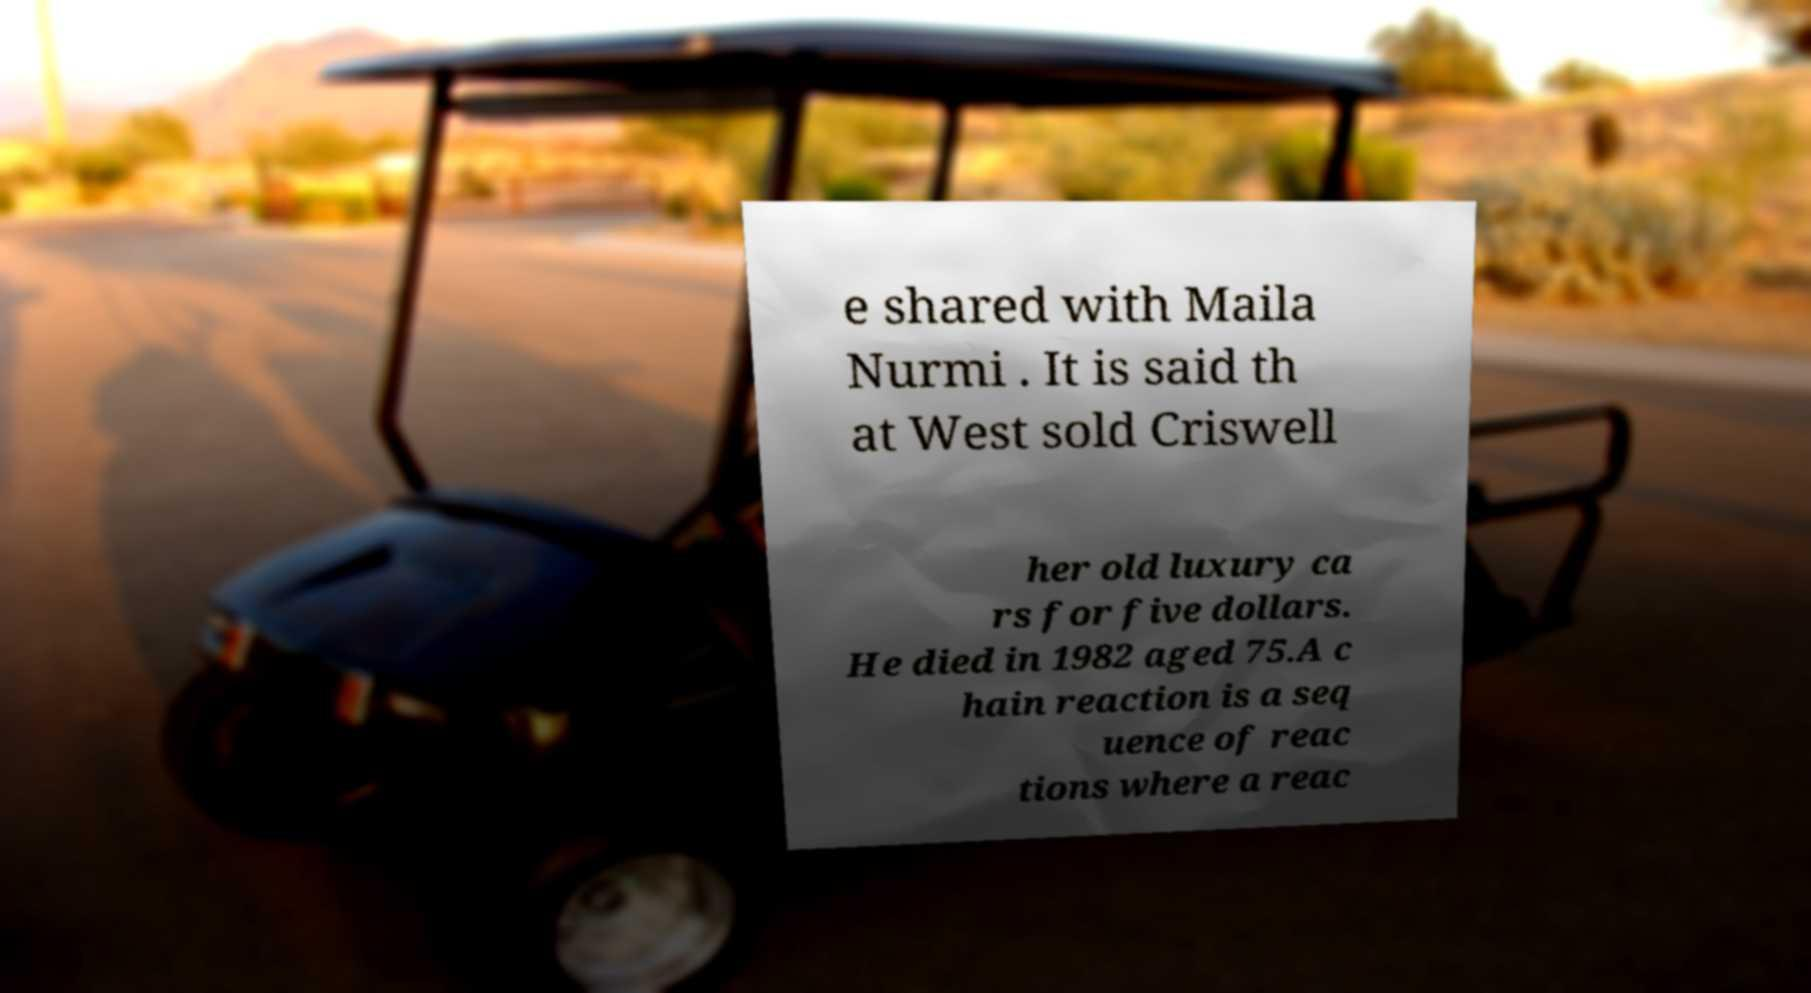There's text embedded in this image that I need extracted. Can you transcribe it verbatim? e shared with Maila Nurmi . It is said th at West sold Criswell her old luxury ca rs for five dollars. He died in 1982 aged 75.A c hain reaction is a seq uence of reac tions where a reac 